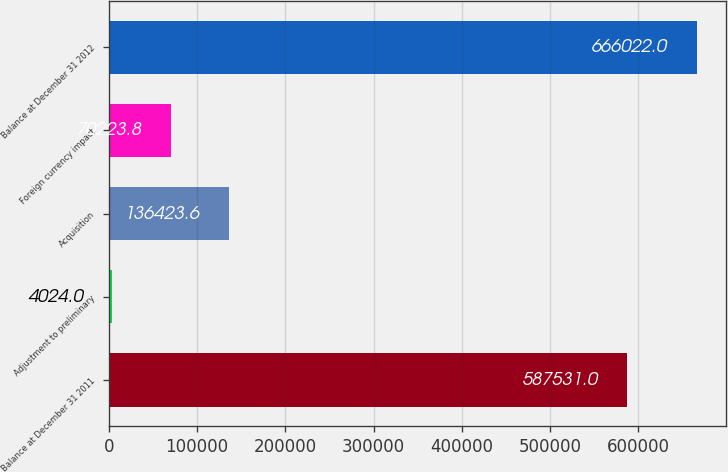<chart> <loc_0><loc_0><loc_500><loc_500><bar_chart><fcel>Balance at December 31 2011<fcel>Adjustment to preliminary<fcel>Acquisition<fcel>Foreign currency impact<fcel>Balance at December 31 2012<nl><fcel>587531<fcel>4024<fcel>136424<fcel>70223.8<fcel>666022<nl></chart> 